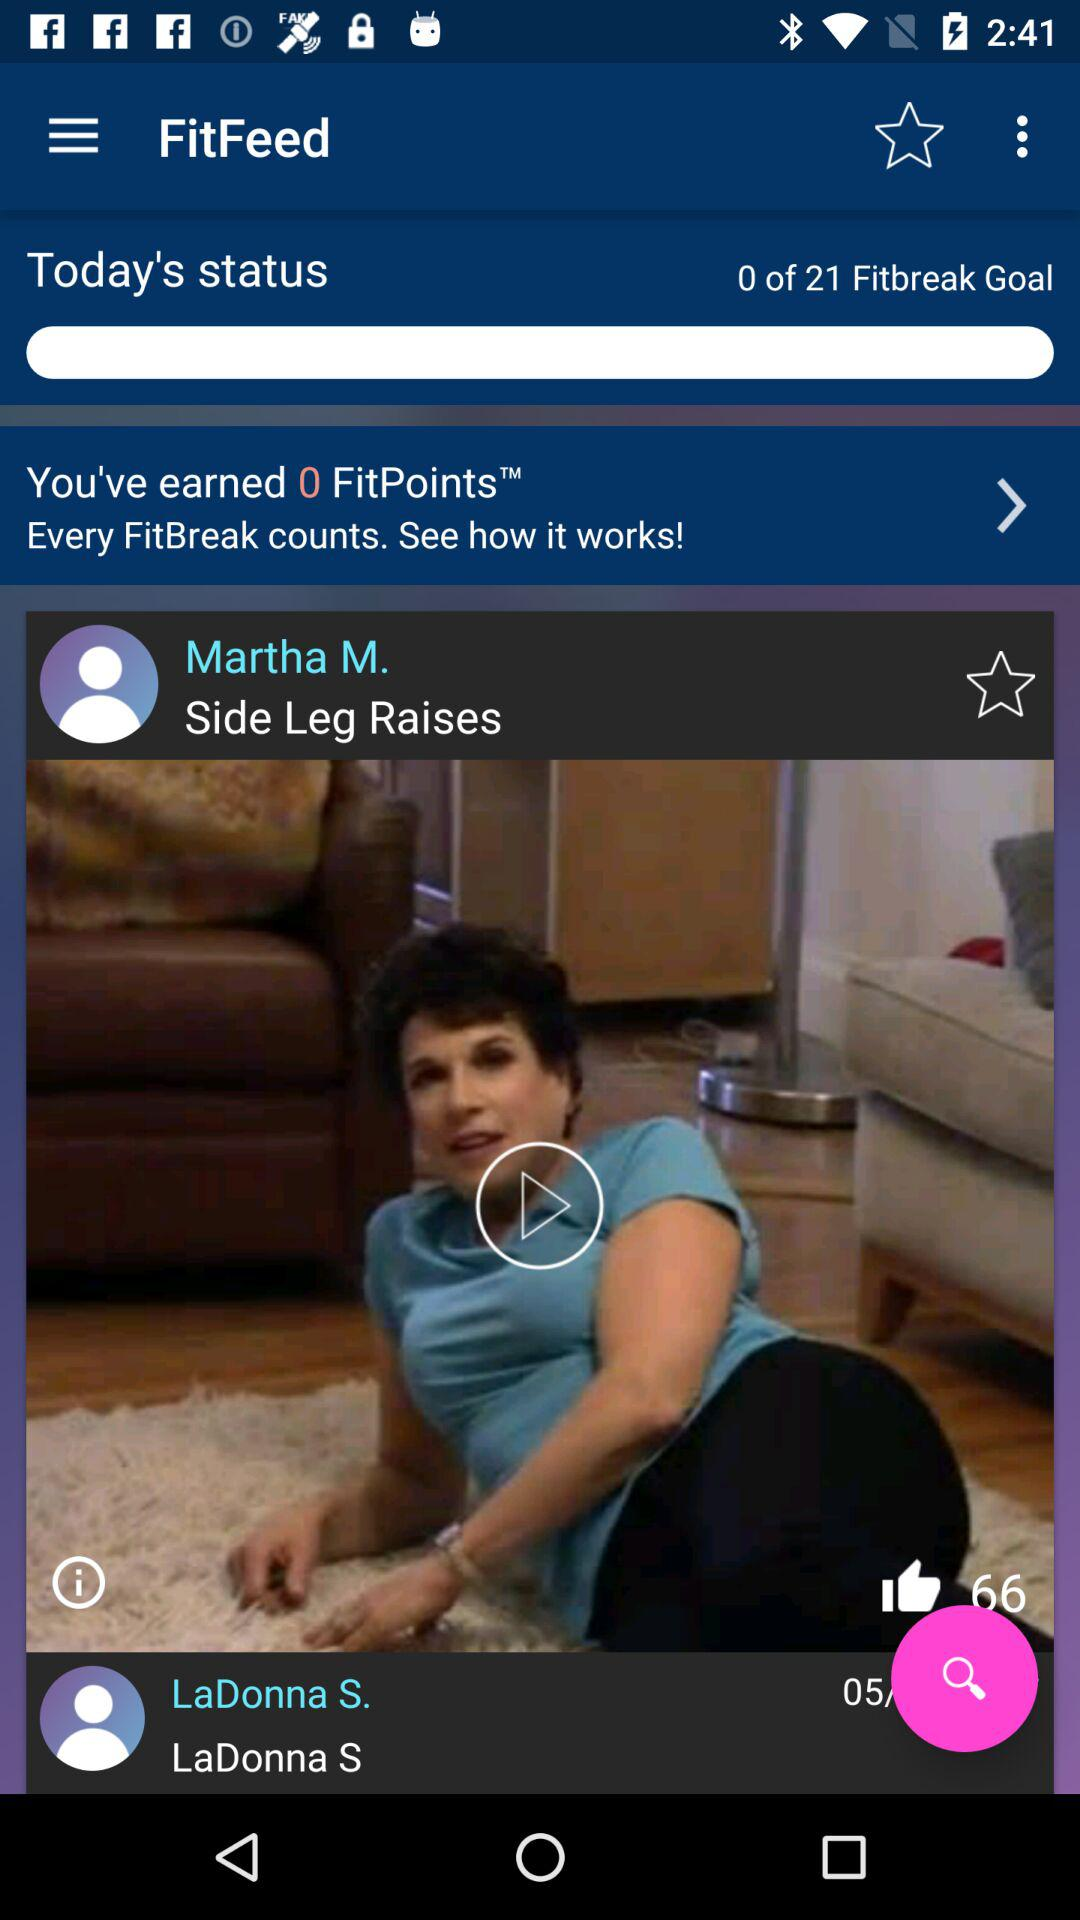How long is the exercise video?
When the provided information is insufficient, respond with <no answer>. <no answer> 